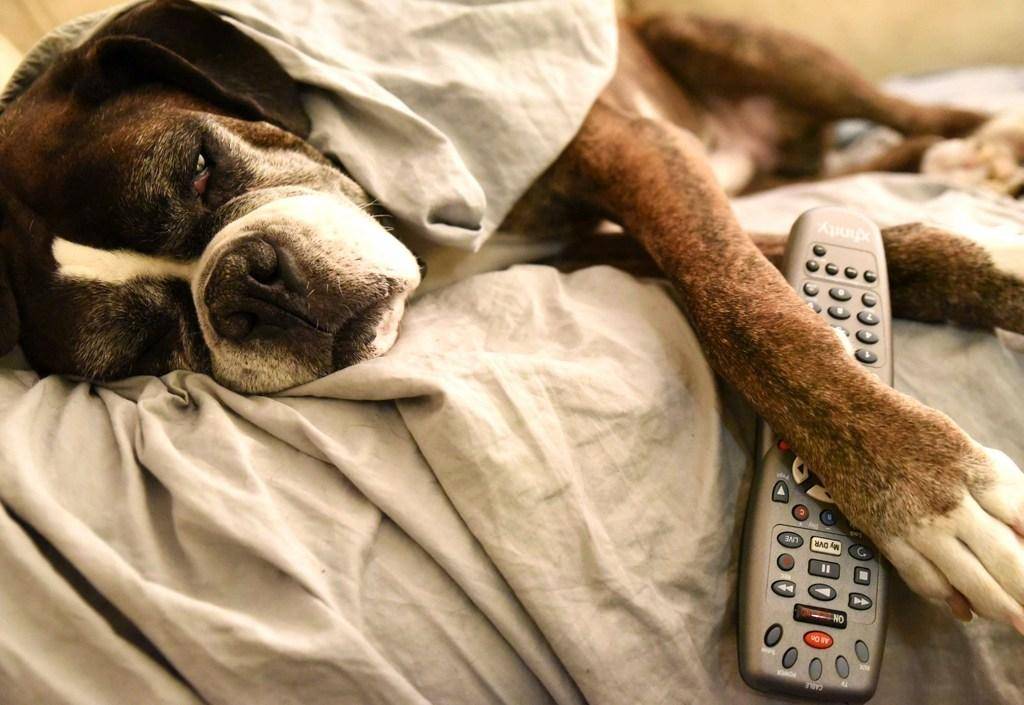What type of animal can be seen in the picture? There is a dog in the picture. Where is the dog located in the image? The dog is laying on the bed. What object is under the dog's leg? There is a remote under the dog's leg. What is covering part of the bed? There is a blanket on the bed. What type of vein is visible on the dog's leg in the image? There are no veins visible on the dog's leg in the image. What door is the dog guarding in the image? There is no door present in the image; the dog is laying on the bed. 